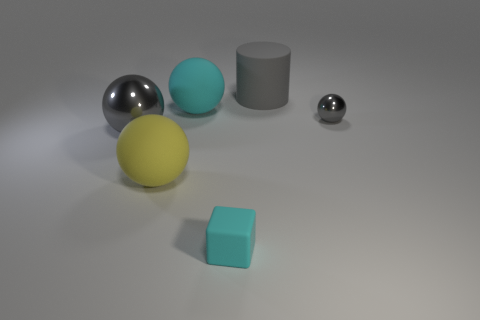There is a tiny thing that is the same material as the gray cylinder; what is its color?
Give a very brief answer. Cyan. Is there a cyan matte sphere of the same size as the gray cylinder?
Offer a terse response. Yes. There is another gray object that is the same shape as the small gray object; what is it made of?
Provide a succinct answer. Metal. There is a gray rubber thing that is the same size as the yellow matte sphere; what is its shape?
Your answer should be compact. Cylinder. Are there any tiny gray things of the same shape as the big cyan rubber thing?
Ensure brevity in your answer.  Yes. The large matte thing that is in front of the gray metallic thing right of the large metal sphere is what shape?
Provide a short and direct response. Sphere. The yellow thing is what shape?
Offer a terse response. Sphere. The big gray object that is right of the large sphere that is behind the thing that is left of the yellow matte ball is made of what material?
Offer a very short reply. Rubber. What number of other objects are the same material as the cyan sphere?
Your answer should be compact. 3. What number of large yellow spheres are in front of the large gray object left of the big gray cylinder?
Ensure brevity in your answer.  1. 